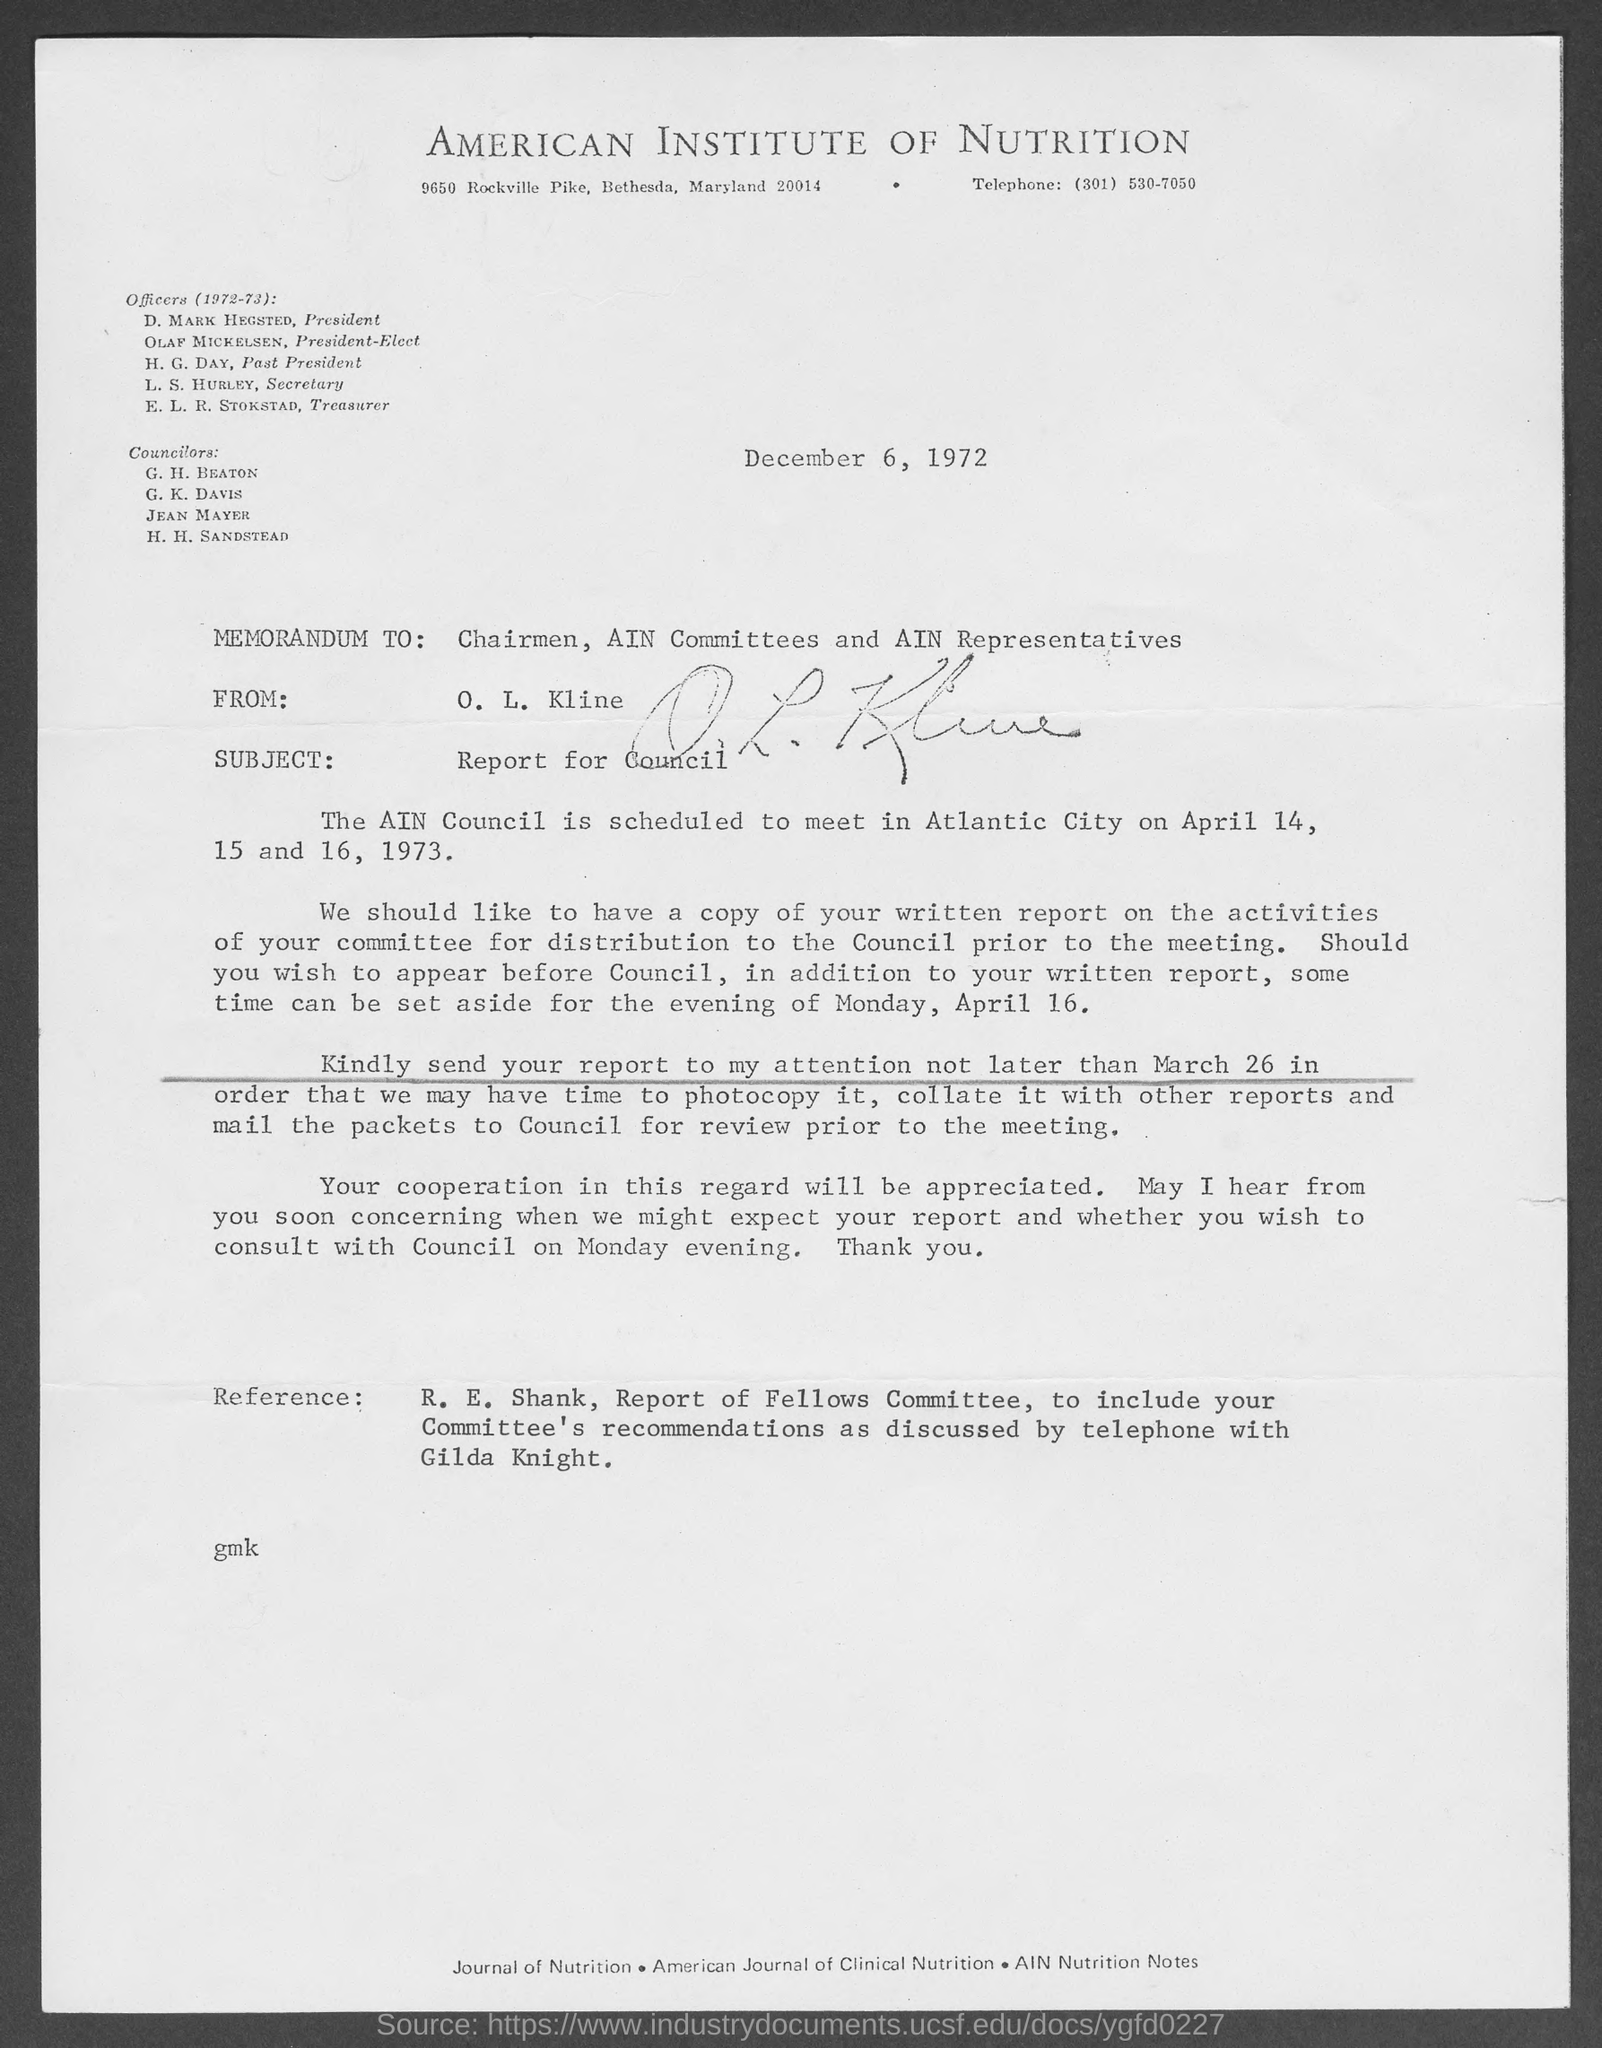Indicate a few pertinent items in this graphic. AIN stands for the American Institute of Nutrition, which is a reputable organization dedicated to advancing the field of nutrition through research and education. The President of the American Institute of Nutrition is D. Mark Hegsted. The telephone number of the American Institute of Nutrition is (301) 530-7050. It is known that the President-Elect of the American Institute of Nutrition is Olaf Mickelsen. The memorandum was dated December 6, 1972. 